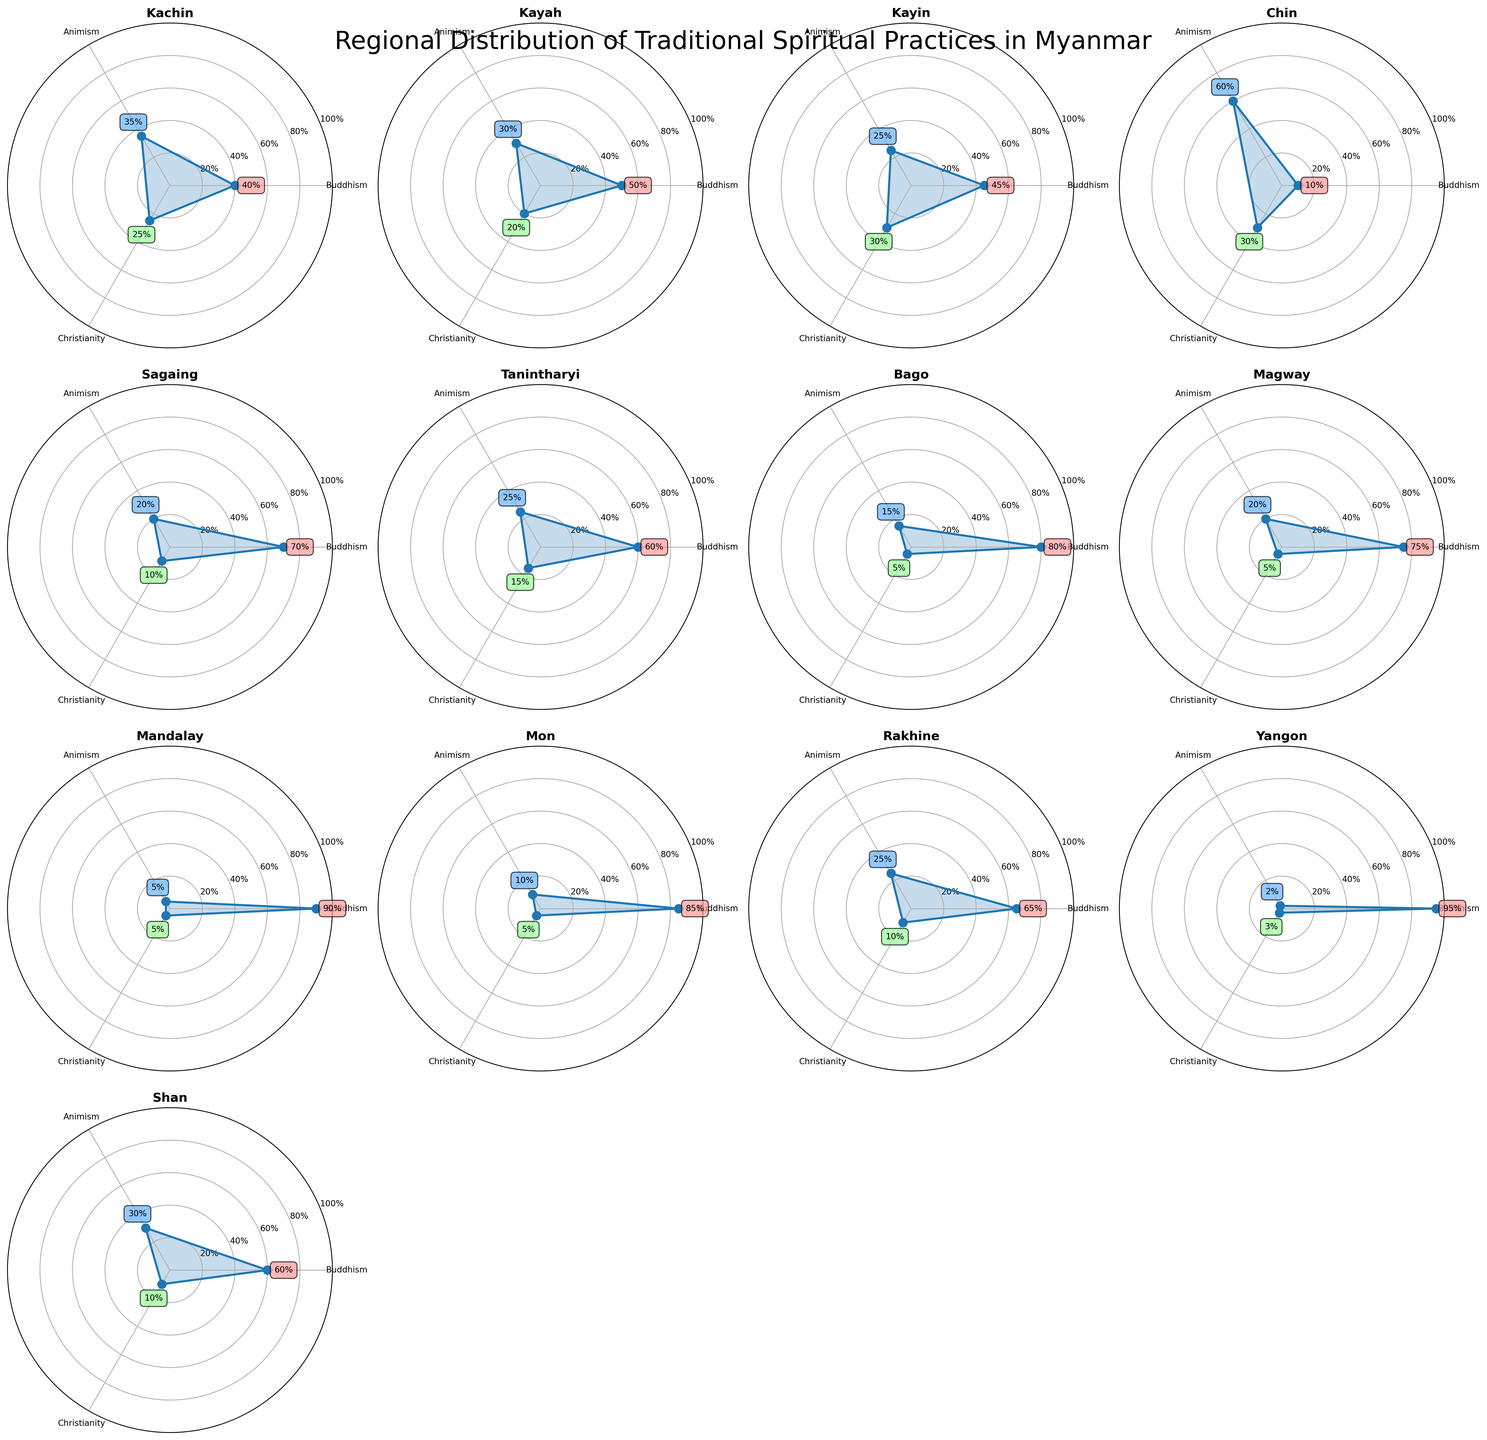Which state has the highest percentage of Animism? To find this, we identify the highest value under Animism in each subplot and observe that Chin state has the highest percentage of 60% in the figure.
Answer: Chin Which state shows the least percentage of Buddhism? By examining the figures, Chin has the lowest Buddhism percentage of 10%.
Answer: Chin What is the average percentage of Christianity across all states? The percentages of Christianity are: 25, 20, 30, 30, 10, 15, 5, 5, 5, 10, 3, 10. Sum these values to get 158, then divide by the number of states, which is 12. The average is 158/12 ≈ 13.17.
Answer: 13.17 Which state has the highest combined percentage of Buddhism and Animism? Sum the percentages of Buddhism and Animism for each state, and see which sum is highest: Yangon (95+2=97) has the highest combined percentage.
Answer: Yangon How do the percentages of Animism in Kachin and Kayah compare? Kachin has 35% Animism and Kayah has 30%. Hence, Kachin has a higher percentage than Kayah.
Answer: Kachin has more Which practice has the highest percentage in Yangon? In Yangon, the Buddhism percentage is 95%, which is the highest among the practices.
Answer: Buddhism Which state has an equal percentage of Buddhism and Christianity? By looking at all subplots, there is no state that has equal percentages of Buddhism and Christianity.
Answer: None How many states have Buddhism percentages over 75%? From each subplot, the states with Buddhism percentages over 75% are Bago, Magway, Mandalay, Mon, and Yangon, totaling 5 states.
Answer: 5 What is the percentage difference between Animism and Christianity in Kayin? In Kayin, Animism is 25% and Christianity is 30%, so the difference is 30% - 25% = 5%.
Answer: 5% Which state has the most even distribution among the three practices? We identify the state with the most similar percentages: Kayin’s values (45%, 25%, 30%) are the closest to even among all states.
Answer: Kayin 